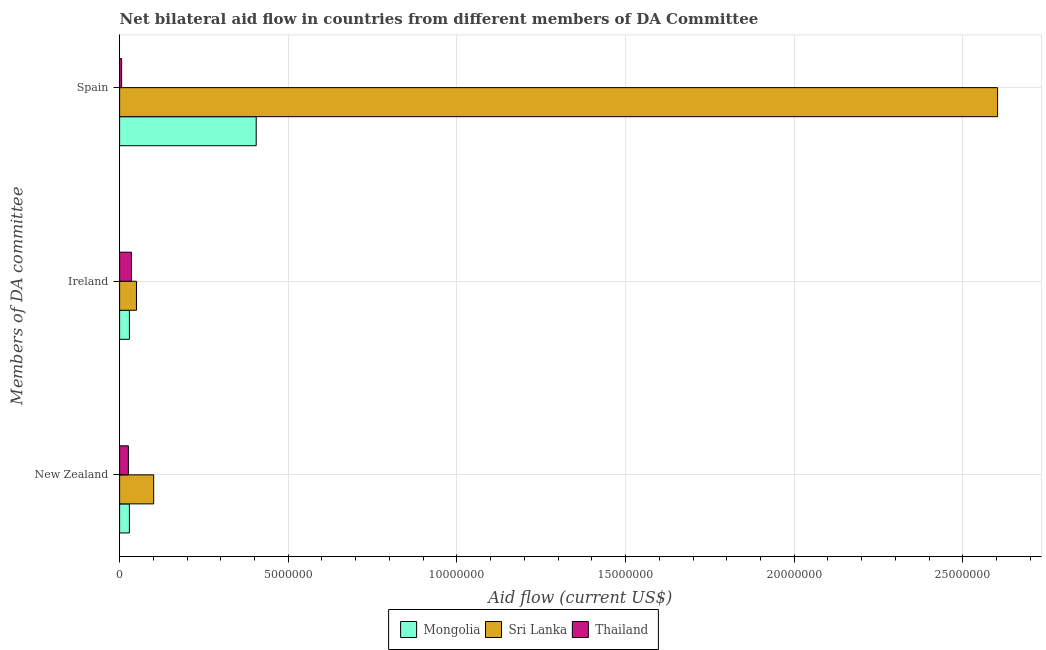How many different coloured bars are there?
Ensure brevity in your answer.  3. How many groups of bars are there?
Offer a very short reply. 3. Are the number of bars per tick equal to the number of legend labels?
Ensure brevity in your answer.  Yes. Are the number of bars on each tick of the Y-axis equal?
Your answer should be very brief. Yes. How many bars are there on the 2nd tick from the top?
Offer a terse response. 3. What is the label of the 2nd group of bars from the top?
Provide a succinct answer. Ireland. What is the amount of aid provided by new zealand in Thailand?
Ensure brevity in your answer.  2.60e+05. Across all countries, what is the maximum amount of aid provided by new zealand?
Your answer should be compact. 1.01e+06. Across all countries, what is the minimum amount of aid provided by ireland?
Ensure brevity in your answer.  2.90e+05. In which country was the amount of aid provided by spain maximum?
Your response must be concise. Sri Lanka. In which country was the amount of aid provided by spain minimum?
Make the answer very short. Thailand. What is the total amount of aid provided by spain in the graph?
Keep it short and to the point. 3.01e+07. What is the difference between the amount of aid provided by new zealand in Mongolia and that in Sri Lanka?
Provide a short and direct response. -7.20e+05. What is the difference between the amount of aid provided by ireland in Thailand and the amount of aid provided by spain in Mongolia?
Provide a succinct answer. -3.70e+06. What is the average amount of aid provided by spain per country?
Provide a succinct answer. 1.00e+07. What is the difference between the amount of aid provided by spain and amount of aid provided by new zealand in Mongolia?
Make the answer very short. 3.76e+06. What is the ratio of the amount of aid provided by spain in Mongolia to that in Sri Lanka?
Your answer should be compact. 0.16. Is the difference between the amount of aid provided by ireland in Mongolia and Thailand greater than the difference between the amount of aid provided by new zealand in Mongolia and Thailand?
Your answer should be very brief. No. What is the difference between the highest and the lowest amount of aid provided by spain?
Keep it short and to the point. 2.60e+07. In how many countries, is the amount of aid provided by new zealand greater than the average amount of aid provided by new zealand taken over all countries?
Provide a succinct answer. 1. Is the sum of the amount of aid provided by new zealand in Sri Lanka and Thailand greater than the maximum amount of aid provided by ireland across all countries?
Keep it short and to the point. Yes. What does the 1st bar from the top in Ireland represents?
Your response must be concise. Thailand. What does the 1st bar from the bottom in Ireland represents?
Keep it short and to the point. Mongolia. Is it the case that in every country, the sum of the amount of aid provided by new zealand and amount of aid provided by ireland is greater than the amount of aid provided by spain?
Make the answer very short. No. How many bars are there?
Ensure brevity in your answer.  9. Are all the bars in the graph horizontal?
Your answer should be compact. Yes. How many countries are there in the graph?
Your answer should be very brief. 3. What is the difference between two consecutive major ticks on the X-axis?
Provide a short and direct response. 5.00e+06. Are the values on the major ticks of X-axis written in scientific E-notation?
Ensure brevity in your answer.  No. How many legend labels are there?
Give a very brief answer. 3. What is the title of the graph?
Offer a terse response. Net bilateral aid flow in countries from different members of DA Committee. What is the label or title of the X-axis?
Give a very brief answer. Aid flow (current US$). What is the label or title of the Y-axis?
Offer a very short reply. Members of DA committee. What is the Aid flow (current US$) in Sri Lanka in New Zealand?
Your response must be concise. 1.01e+06. What is the Aid flow (current US$) in Mongolia in Ireland?
Give a very brief answer. 2.90e+05. What is the Aid flow (current US$) in Mongolia in Spain?
Keep it short and to the point. 4.05e+06. What is the Aid flow (current US$) in Sri Lanka in Spain?
Ensure brevity in your answer.  2.60e+07. What is the Aid flow (current US$) in Thailand in Spain?
Your answer should be very brief. 6.00e+04. Across all Members of DA committee, what is the maximum Aid flow (current US$) of Mongolia?
Provide a succinct answer. 4.05e+06. Across all Members of DA committee, what is the maximum Aid flow (current US$) of Sri Lanka?
Ensure brevity in your answer.  2.60e+07. Across all Members of DA committee, what is the minimum Aid flow (current US$) in Mongolia?
Provide a short and direct response. 2.90e+05. What is the total Aid flow (current US$) in Mongolia in the graph?
Your answer should be very brief. 4.63e+06. What is the total Aid flow (current US$) of Sri Lanka in the graph?
Offer a very short reply. 2.75e+07. What is the total Aid flow (current US$) of Thailand in the graph?
Your answer should be compact. 6.70e+05. What is the difference between the Aid flow (current US$) of Sri Lanka in New Zealand and that in Ireland?
Keep it short and to the point. 5.10e+05. What is the difference between the Aid flow (current US$) of Thailand in New Zealand and that in Ireland?
Offer a terse response. -9.00e+04. What is the difference between the Aid flow (current US$) of Mongolia in New Zealand and that in Spain?
Offer a very short reply. -3.76e+06. What is the difference between the Aid flow (current US$) in Sri Lanka in New Zealand and that in Spain?
Provide a succinct answer. -2.50e+07. What is the difference between the Aid flow (current US$) in Mongolia in Ireland and that in Spain?
Keep it short and to the point. -3.76e+06. What is the difference between the Aid flow (current US$) in Sri Lanka in Ireland and that in Spain?
Make the answer very short. -2.55e+07. What is the difference between the Aid flow (current US$) of Thailand in Ireland and that in Spain?
Provide a succinct answer. 2.90e+05. What is the difference between the Aid flow (current US$) of Mongolia in New Zealand and the Aid flow (current US$) of Sri Lanka in Ireland?
Provide a short and direct response. -2.10e+05. What is the difference between the Aid flow (current US$) in Mongolia in New Zealand and the Aid flow (current US$) in Thailand in Ireland?
Ensure brevity in your answer.  -6.00e+04. What is the difference between the Aid flow (current US$) in Sri Lanka in New Zealand and the Aid flow (current US$) in Thailand in Ireland?
Make the answer very short. 6.60e+05. What is the difference between the Aid flow (current US$) of Mongolia in New Zealand and the Aid flow (current US$) of Sri Lanka in Spain?
Ensure brevity in your answer.  -2.57e+07. What is the difference between the Aid flow (current US$) of Sri Lanka in New Zealand and the Aid flow (current US$) of Thailand in Spain?
Ensure brevity in your answer.  9.50e+05. What is the difference between the Aid flow (current US$) of Mongolia in Ireland and the Aid flow (current US$) of Sri Lanka in Spain?
Provide a succinct answer. -2.57e+07. What is the difference between the Aid flow (current US$) of Mongolia in Ireland and the Aid flow (current US$) of Thailand in Spain?
Offer a terse response. 2.30e+05. What is the average Aid flow (current US$) in Mongolia per Members of DA committee?
Give a very brief answer. 1.54e+06. What is the average Aid flow (current US$) in Sri Lanka per Members of DA committee?
Provide a succinct answer. 9.18e+06. What is the average Aid flow (current US$) in Thailand per Members of DA committee?
Provide a succinct answer. 2.23e+05. What is the difference between the Aid flow (current US$) of Mongolia and Aid flow (current US$) of Sri Lanka in New Zealand?
Keep it short and to the point. -7.20e+05. What is the difference between the Aid flow (current US$) of Mongolia and Aid flow (current US$) of Thailand in New Zealand?
Provide a short and direct response. 3.00e+04. What is the difference between the Aid flow (current US$) of Sri Lanka and Aid flow (current US$) of Thailand in New Zealand?
Make the answer very short. 7.50e+05. What is the difference between the Aid flow (current US$) of Mongolia and Aid flow (current US$) of Sri Lanka in Ireland?
Ensure brevity in your answer.  -2.10e+05. What is the difference between the Aid flow (current US$) of Mongolia and Aid flow (current US$) of Sri Lanka in Spain?
Offer a very short reply. -2.20e+07. What is the difference between the Aid flow (current US$) of Mongolia and Aid flow (current US$) of Thailand in Spain?
Provide a short and direct response. 3.99e+06. What is the difference between the Aid flow (current US$) of Sri Lanka and Aid flow (current US$) of Thailand in Spain?
Offer a very short reply. 2.60e+07. What is the ratio of the Aid flow (current US$) of Sri Lanka in New Zealand to that in Ireland?
Make the answer very short. 2.02. What is the ratio of the Aid flow (current US$) of Thailand in New Zealand to that in Ireland?
Your response must be concise. 0.74. What is the ratio of the Aid flow (current US$) in Mongolia in New Zealand to that in Spain?
Your answer should be compact. 0.07. What is the ratio of the Aid flow (current US$) in Sri Lanka in New Zealand to that in Spain?
Your response must be concise. 0.04. What is the ratio of the Aid flow (current US$) of Thailand in New Zealand to that in Spain?
Provide a short and direct response. 4.33. What is the ratio of the Aid flow (current US$) in Mongolia in Ireland to that in Spain?
Give a very brief answer. 0.07. What is the ratio of the Aid flow (current US$) in Sri Lanka in Ireland to that in Spain?
Offer a very short reply. 0.02. What is the ratio of the Aid flow (current US$) in Thailand in Ireland to that in Spain?
Your answer should be compact. 5.83. What is the difference between the highest and the second highest Aid flow (current US$) of Mongolia?
Your answer should be very brief. 3.76e+06. What is the difference between the highest and the second highest Aid flow (current US$) of Sri Lanka?
Offer a terse response. 2.50e+07. What is the difference between the highest and the lowest Aid flow (current US$) in Mongolia?
Make the answer very short. 3.76e+06. What is the difference between the highest and the lowest Aid flow (current US$) of Sri Lanka?
Give a very brief answer. 2.55e+07. 